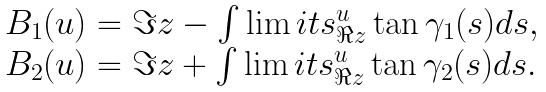Convert formula to latex. <formula><loc_0><loc_0><loc_500><loc_500>\begin{array} { l } B _ { 1 } ( u ) = \Im z - \int \lim i t s _ { \Re z } ^ { u } \tan \gamma _ { 1 } ( s ) d s , \\ B _ { 2 } ( u ) = \Im z + \int \lim i t s _ { \Re z } ^ { u } \tan \gamma _ { 2 } ( s ) d s . \end{array}</formula> 